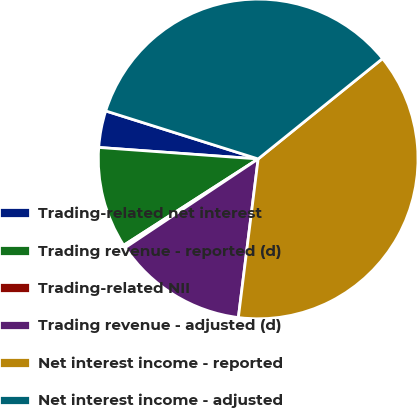<chart> <loc_0><loc_0><loc_500><loc_500><pie_chart><fcel>Trading-related net interest<fcel>Trading revenue - reported (d)<fcel>Trading-related NII<fcel>Trading revenue - adjusted (d)<fcel>Net interest income - reported<fcel>Net interest income - adjusted<nl><fcel>3.71%<fcel>10.23%<fcel>0.28%<fcel>13.66%<fcel>37.78%<fcel>34.34%<nl></chart> 